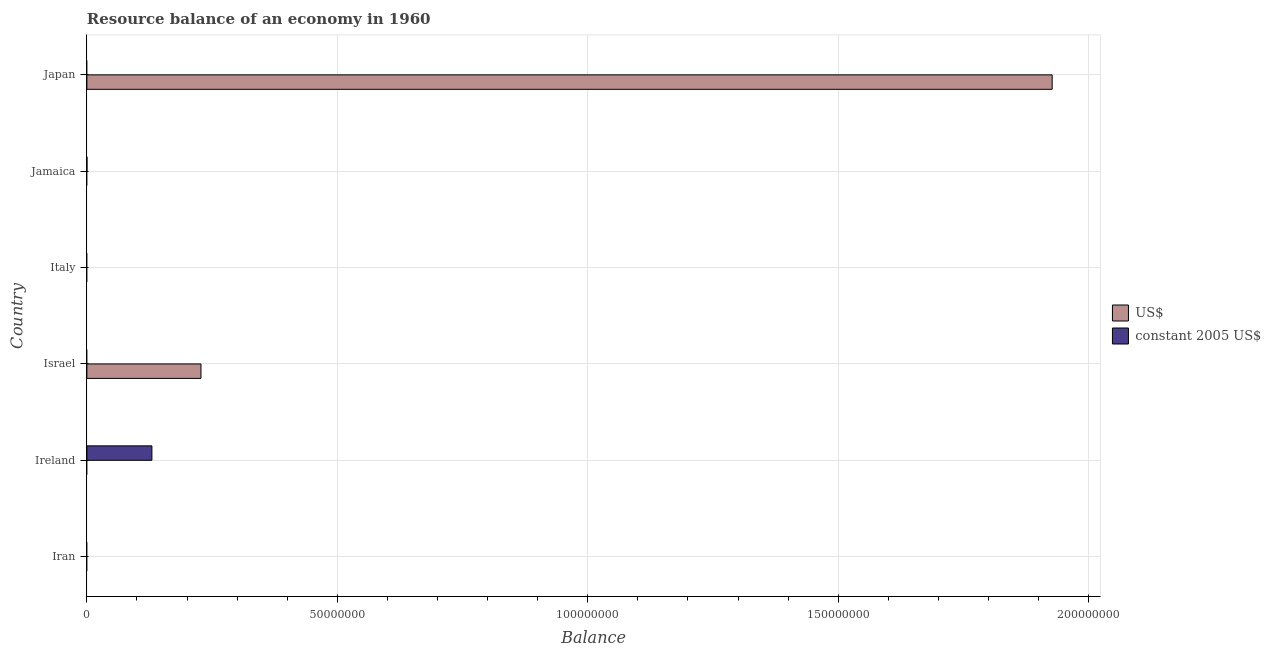How many different coloured bars are there?
Your answer should be compact. 2. What is the label of the 4th group of bars from the top?
Your response must be concise. Israel. In how many cases, is the number of bars for a given country not equal to the number of legend labels?
Give a very brief answer. 6. Across all countries, what is the maximum resource balance in constant us$?
Your answer should be very brief. 1.30e+07. In which country was the resource balance in constant us$ maximum?
Ensure brevity in your answer.  Ireland. What is the total resource balance in us$ in the graph?
Offer a terse response. 2.16e+08. What is the average resource balance in constant us$ per country?
Make the answer very short. 2.16e+06. In how many countries, is the resource balance in constant us$ greater than 190000000 units?
Make the answer very short. 0. What is the difference between the highest and the lowest resource balance in constant us$?
Your response must be concise. 1.30e+07. Are all the bars in the graph horizontal?
Make the answer very short. Yes. Are the values on the major ticks of X-axis written in scientific E-notation?
Offer a terse response. No. Does the graph contain any zero values?
Your response must be concise. Yes. How are the legend labels stacked?
Your answer should be compact. Vertical. What is the title of the graph?
Your answer should be compact. Resource balance of an economy in 1960. Does "By country of origin" appear as one of the legend labels in the graph?
Ensure brevity in your answer.  No. What is the label or title of the X-axis?
Your answer should be very brief. Balance. What is the label or title of the Y-axis?
Keep it short and to the point. Country. What is the Balance in US$ in Iran?
Provide a succinct answer. 0. What is the Balance of constant 2005 US$ in Ireland?
Provide a succinct answer. 1.30e+07. What is the Balance of US$ in Israel?
Offer a terse response. 2.28e+07. What is the Balance in constant 2005 US$ in Israel?
Offer a very short reply. 0. What is the Balance of US$ in Italy?
Your answer should be compact. 0. What is the Balance of US$ in Jamaica?
Offer a terse response. 0. What is the Balance in constant 2005 US$ in Jamaica?
Keep it short and to the point. 4100. What is the Balance in US$ in Japan?
Your answer should be very brief. 1.93e+08. What is the Balance of constant 2005 US$ in Japan?
Offer a terse response. 0. Across all countries, what is the maximum Balance of US$?
Your response must be concise. 1.93e+08. Across all countries, what is the maximum Balance in constant 2005 US$?
Offer a terse response. 1.30e+07. What is the total Balance of US$ in the graph?
Your response must be concise. 2.16e+08. What is the total Balance in constant 2005 US$ in the graph?
Offer a terse response. 1.30e+07. What is the difference between the Balance of constant 2005 US$ in Ireland and that in Jamaica?
Provide a short and direct response. 1.30e+07. What is the difference between the Balance in US$ in Israel and that in Japan?
Provide a succinct answer. -1.70e+08. What is the difference between the Balance in US$ in Israel and the Balance in constant 2005 US$ in Jamaica?
Your response must be concise. 2.28e+07. What is the average Balance in US$ per country?
Give a very brief answer. 3.59e+07. What is the average Balance of constant 2005 US$ per country?
Make the answer very short. 2.16e+06. What is the ratio of the Balance of constant 2005 US$ in Ireland to that in Jamaica?
Offer a very short reply. 3166.17. What is the ratio of the Balance of US$ in Israel to that in Japan?
Ensure brevity in your answer.  0.12. What is the difference between the highest and the lowest Balance of US$?
Ensure brevity in your answer.  1.93e+08. What is the difference between the highest and the lowest Balance of constant 2005 US$?
Your answer should be compact. 1.30e+07. 